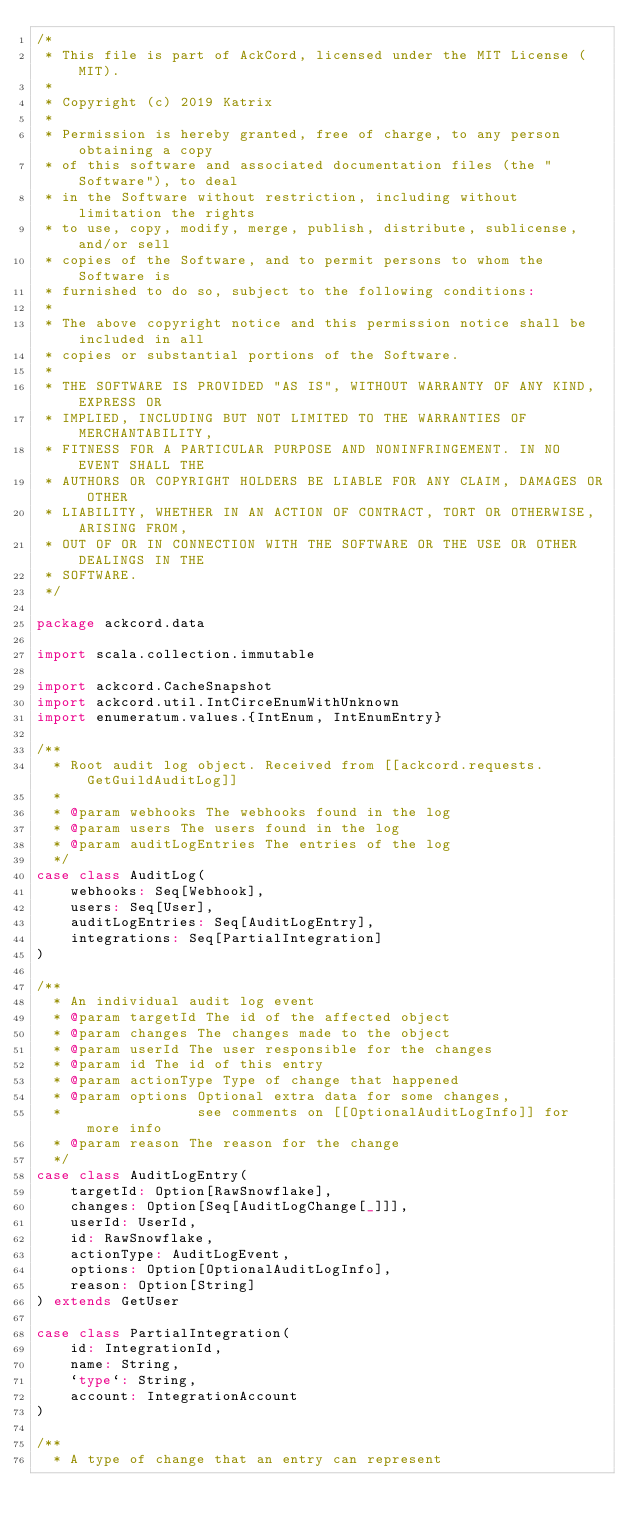Convert code to text. <code><loc_0><loc_0><loc_500><loc_500><_Scala_>/*
 * This file is part of AckCord, licensed under the MIT License (MIT).
 *
 * Copyright (c) 2019 Katrix
 *
 * Permission is hereby granted, free of charge, to any person obtaining a copy
 * of this software and associated documentation files (the "Software"), to deal
 * in the Software without restriction, including without limitation the rights
 * to use, copy, modify, merge, publish, distribute, sublicense, and/or sell
 * copies of the Software, and to permit persons to whom the Software is
 * furnished to do so, subject to the following conditions:
 *
 * The above copyright notice and this permission notice shall be included in all
 * copies or substantial portions of the Software.
 *
 * THE SOFTWARE IS PROVIDED "AS IS", WITHOUT WARRANTY OF ANY KIND, EXPRESS OR
 * IMPLIED, INCLUDING BUT NOT LIMITED TO THE WARRANTIES OF MERCHANTABILITY,
 * FITNESS FOR A PARTICULAR PURPOSE AND NONINFRINGEMENT. IN NO EVENT SHALL THE
 * AUTHORS OR COPYRIGHT HOLDERS BE LIABLE FOR ANY CLAIM, DAMAGES OR OTHER
 * LIABILITY, WHETHER IN AN ACTION OF CONTRACT, TORT OR OTHERWISE, ARISING FROM,
 * OUT OF OR IN CONNECTION WITH THE SOFTWARE OR THE USE OR OTHER DEALINGS IN THE
 * SOFTWARE.
 */

package ackcord.data

import scala.collection.immutable

import ackcord.CacheSnapshot
import ackcord.util.IntCirceEnumWithUnknown
import enumeratum.values.{IntEnum, IntEnumEntry}

/**
  * Root audit log object. Received from [[ackcord.requests.GetGuildAuditLog]]
  *
  * @param webhooks The webhooks found in the log
  * @param users The users found in the log
  * @param auditLogEntries The entries of the log
  */
case class AuditLog(
    webhooks: Seq[Webhook],
    users: Seq[User],
    auditLogEntries: Seq[AuditLogEntry],
    integrations: Seq[PartialIntegration]
)

/**
  * An individual audit log event
  * @param targetId The id of the affected object
  * @param changes The changes made to the object
  * @param userId The user responsible for the changes
  * @param id The id of this entry
  * @param actionType Type of change that happened
  * @param options Optional extra data for some changes,
  *                see comments on [[OptionalAuditLogInfo]] for more info
  * @param reason The reason for the change
  */
case class AuditLogEntry(
    targetId: Option[RawSnowflake],
    changes: Option[Seq[AuditLogChange[_]]],
    userId: UserId,
    id: RawSnowflake,
    actionType: AuditLogEvent,
    options: Option[OptionalAuditLogInfo],
    reason: Option[String]
) extends GetUser

case class PartialIntegration(
    id: IntegrationId,
    name: String,
    `type`: String,
    account: IntegrationAccount
)

/**
  * A type of change that an entry can represent</code> 